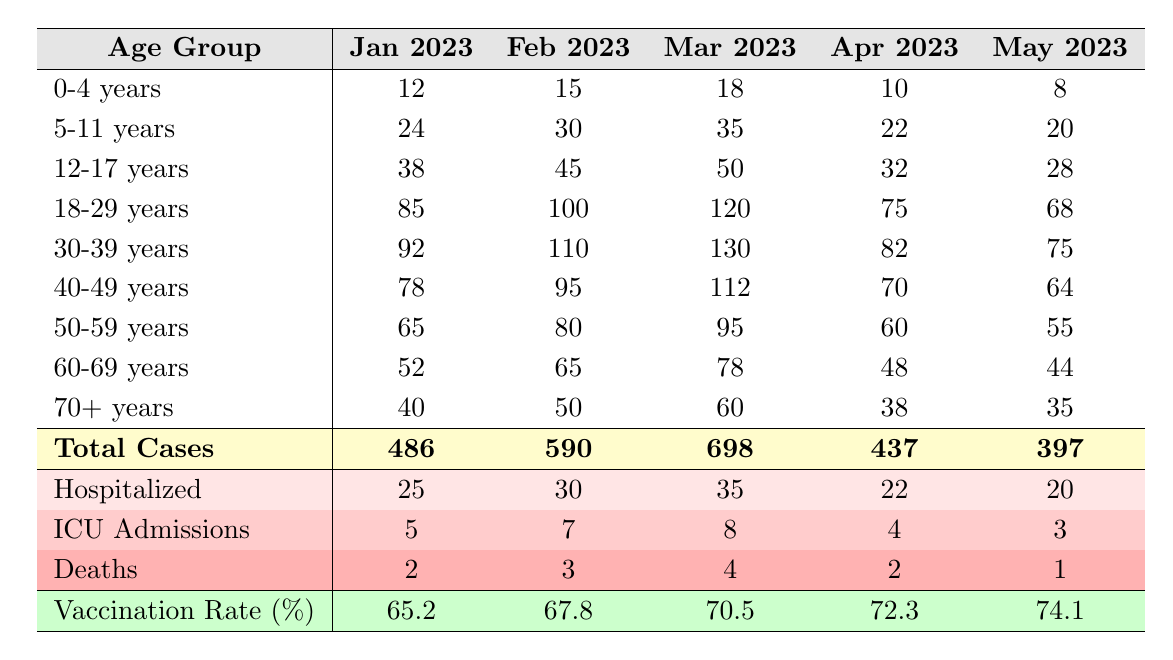What was the total number of COVID-19 cases reported in March 2023? The table lists the total cases for each month, and for March 2023, the total cases are clearly indicated as 698.
Answer: 698 Which age group had the highest number of cases in January 2023? Looking at the January 2023 column, the age group 18-29 years has the highest number of cases at 85, compared to other age groups.
Answer: 18-29 years What is the decrease in cases for the age group 60-69 years from February to May 2023? From the table, in February 2023, the cases were 65, and in May 2023, they dropped to 44. The decrease is calculated as 65 - 44 = 21.
Answer: 21 In which month did the 0-4 years age group report the least cases? By examining the 0-4 years row across all columns, the least cases is found in May 2023 with 8 cases.
Answer: May 2023 What is the average number of cases for the age group 30-39 years over the five months? The cases for the age group 30-39 years are 92, 110, 130, 82, and 75. Summing them gives 489, and dividing by 5 gives an average of 489 / 5 = 97.8.
Answer: 97.8 Did the hospitalization rates increase or decrease from January 2023 to May 2023? In January 2023, there were 25 hospitalized cases and in May 2023, there were 20. This indicates a decrease as 20 is less than 25.
Answer: Decrease What was the total number of deaths from January to May 2023? The number of deaths for each month is 2, 3, 4, 2, and 1. Summing these gives 2 + 3 + 4 + 2 + 1 = 12 deaths in total.
Answer: 12 Which month experienced the highest number of ICU admissions? The ICU admissions for each month were 5, 7, 8, 4, and 3. The highest recorded was 8 in March 2023.
Answer: March 2023 Is the vaccination rate consistently increasing from January to May 2023? By examining the vaccination rates, we see they progress as 65.2, 67.8, 70.5, 72.3, and 74.1, indicating a consistent increase over the months.
Answer: Yes What age group experienced the highest hospitalization rate in April 2023? The hospitalization row shows 22 for April 2023. Evaluating age groups, none exceed this number, so the highest hospitalization rate in April 2023 for all eligible groups remained low.
Answer: N/A 